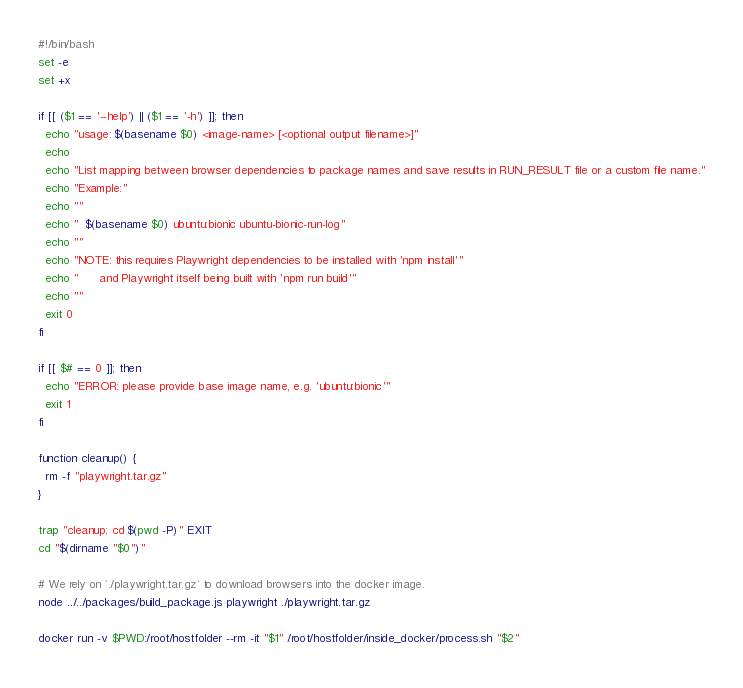Convert code to text. <code><loc_0><loc_0><loc_500><loc_500><_Bash_>#!/bin/bash
set -e
set +x

if [[ ($1 == '--help') || ($1 == '-h') ]]; then
  echo "usage: $(basename $0) <image-name> [<optional output filename>]"
  echo
  echo "List mapping between browser dependencies to package names and save results in RUN_RESULT file or a custom file name."
  echo "Example:"
  echo ""
  echo "  $(basename $0) ubuntu:bionic ubuntu-bionic-run-log"
  echo ""
  echo "NOTE: this requires Playwright dependencies to be installed with 'npm install'"
  echo "      and Playwright itself being built with 'npm run build'"
  echo ""
  exit 0
fi

if [[ $# == 0 ]]; then
  echo "ERROR: please provide base image name, e.g. 'ubuntu:bionic'"
  exit 1
fi

function cleanup() {
  rm -f "playwright.tar.gz"
}

trap "cleanup; cd $(pwd -P)" EXIT
cd "$(dirname "$0")"

# We rely on `./playwright.tar.gz` to download browsers into the docker image.
node ../../packages/build_package.js playwright ./playwright.tar.gz

docker run -v $PWD:/root/hostfolder --rm -it "$1" /root/hostfolder/inside_docker/process.sh "$2"

</code> 